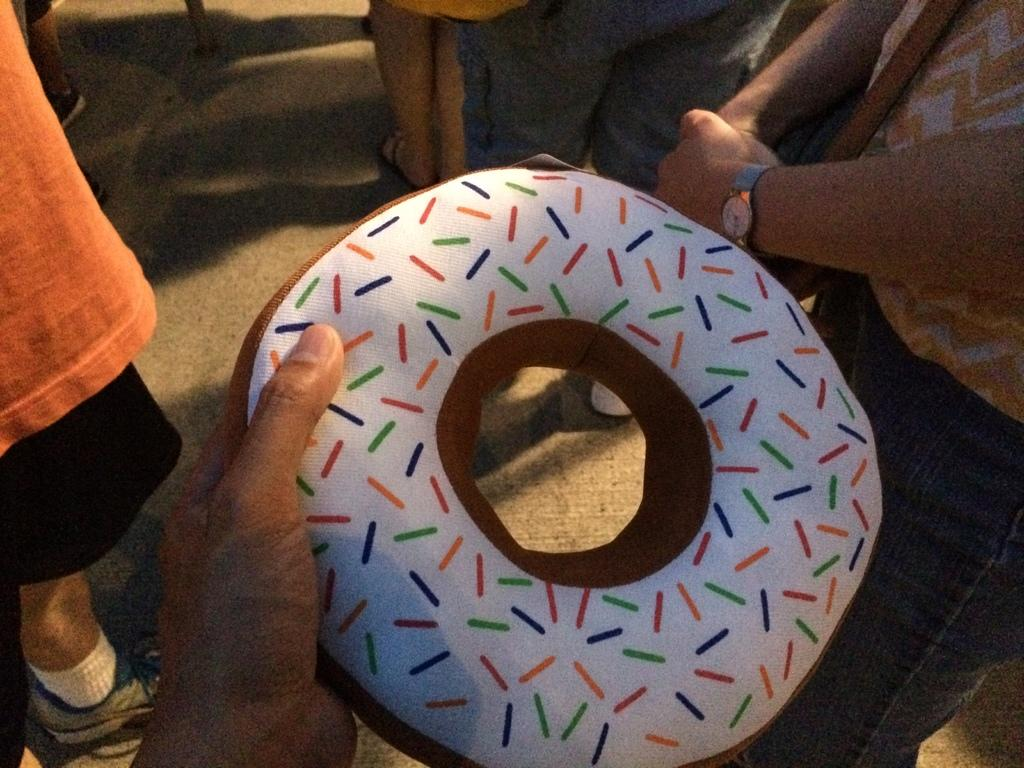What is happening in the image? There are people standing in the image. Can you describe what one of the people is holding? There is a person holding a white and brown object in the image. What type of roof is visible in the image? There is no roof visible in the image; it only shows people standing. What kind of surprise is being held by the person in the image? There is no surprise visible in the image; the person is holding a white and brown object, but it is not specified as a surprise. 